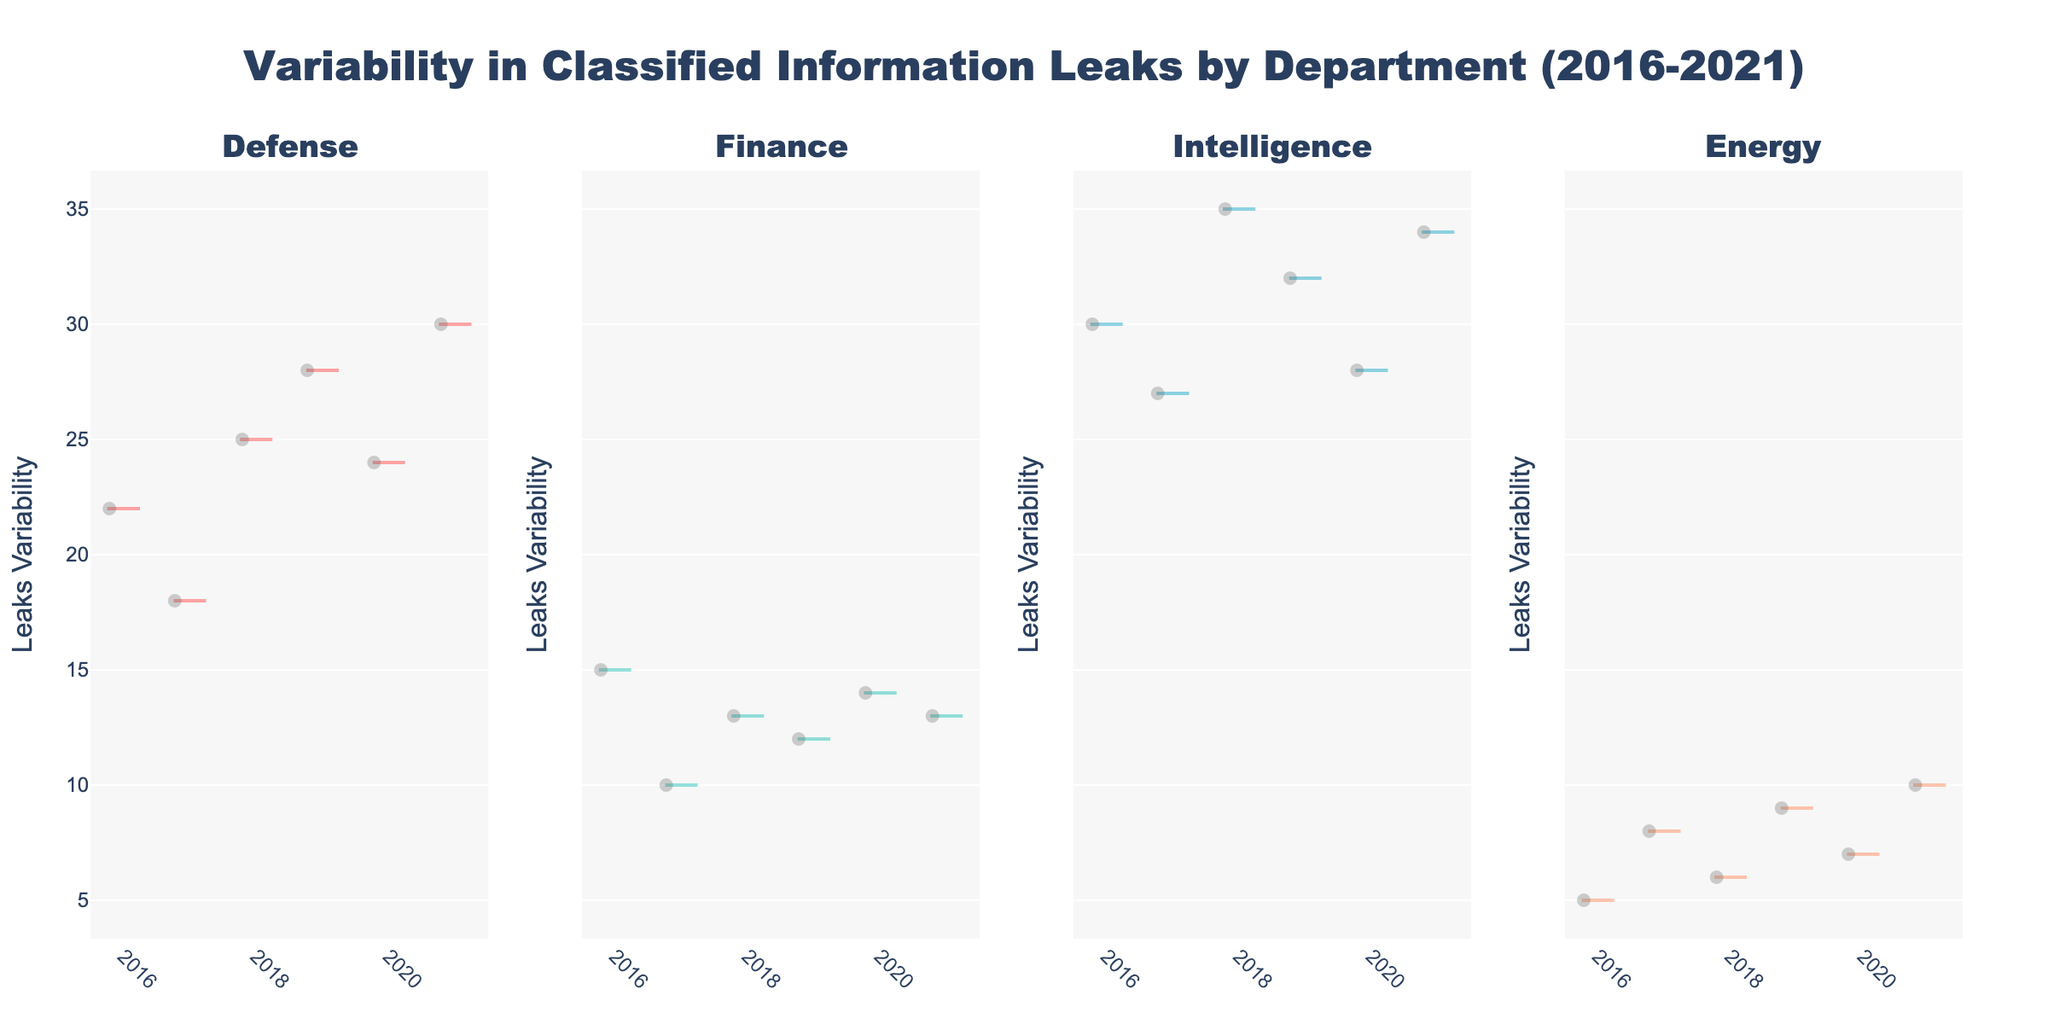What is the title of the plot? The title is visible at the top of the figure. It reads: "Variability in Classified Information Leaks by Department (2016-2021)"
Answer: Variability in Classified Information Leaks by Department (2016-2021) Which department has the highest median value for leaks variability? By looking at the middle line in each violin plot, we can see that the Intelligence department consistently has the highest median value across all years.
Answer: Intelligence Which year shows the lowest leaks variability for the Energy department? The Energy department's violin plots are examined for the lowest values. The year 2016 shows the lowest leaks variability.
Answer: 2016 What is the approximate range of leaks variability for the Defense department in 2019? The range can be determined by observing the spread of the violin plot for Defense in 2019. The variability ranges approximately from 20 to 36.
Answer: 20 to 36 How does the leaks variability in the Finance department in 2017 compare to 2021? By examining the position and spread of the violin plots, it is observed that the variability in Finance was lower in 2017 compared to 2021.
Answer: Lower in 2017 Which department has shown the most consistent leaks variability over the years? A consistent variability would show less spread and lower fluctuation in the median values. The Energy department has the most consistent leaks variability over the years.
Answer: Energy What observation can be made about the leaks variability in the Intelligence department from 2016 to 2021? Observing the violin plots for Intelligence, it is clear that the variability has remained consistently high across all years with a slight increase in later years.
Answer: Consistently high with a slight increase Can we determine if the leaks variability in the Defense department is increasing or decreasing over the years? By examining the median values and spread from each year’s violin plot for Defense, it shows an overall increasing trend from 2016 to 2021.
Answer: Increasing Which years show the highest leaks variability across all departments? By comparing the spreads of the violin plots in all years and departments, the years 2018 and 2021 show the highest leaks variability.
Answer: 2018 and 2021 Does the Finance department show any year with an outlier in leaks variability? Outliers in violin plots are shown as individual points outside the main body. No significant outliers are present in the Finance department's plots.
Answer: No 